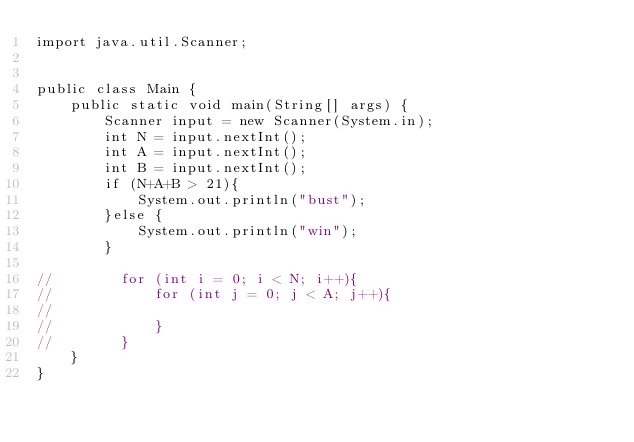<code> <loc_0><loc_0><loc_500><loc_500><_Java_>import java.util.Scanner;


public class Main {
    public static void main(String[] args) {
        Scanner input = new Scanner(System.in);
        int N = input.nextInt();
        int A = input.nextInt();
        int B = input.nextInt();
        if (N+A+B > 21){
            System.out.println("bust");
        }else {
            System.out.println("win");
        }

//        for (int i = 0; i < N; i++){
//            for (int j = 0; j < A; j++){
//
//            }
//        }
    }
}
</code> 